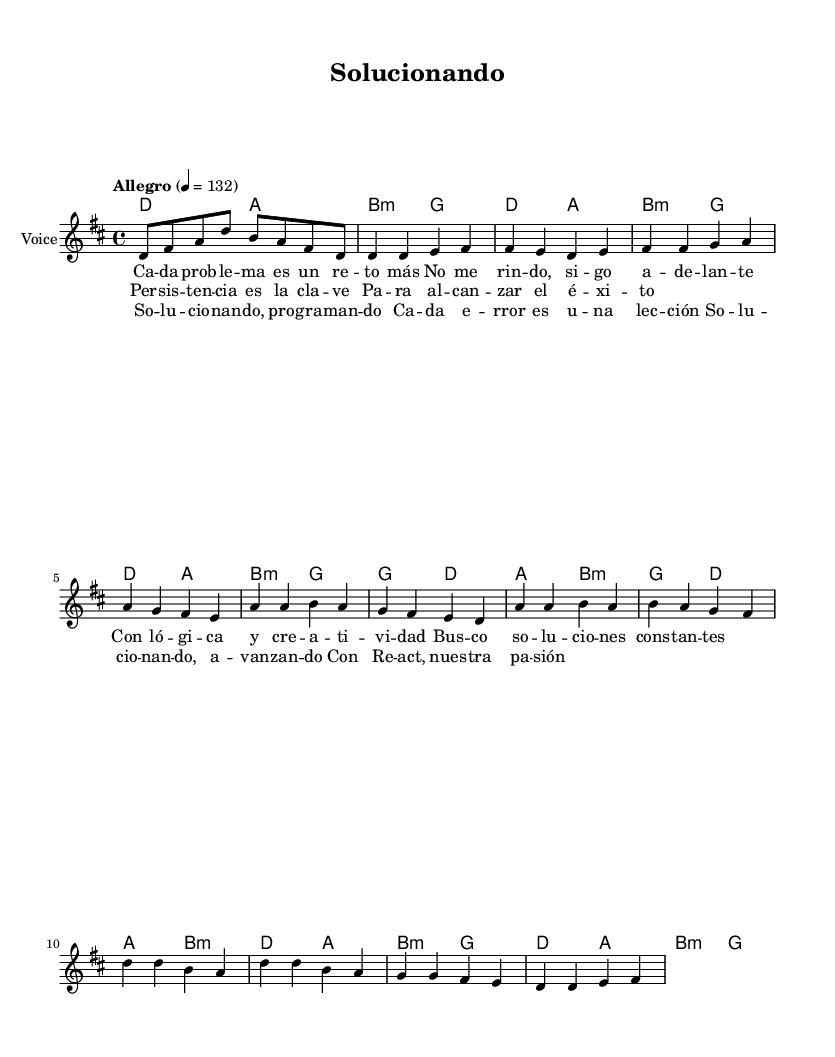What is the key signature of this music? The key signature is D major, which has F sharp and C sharp notes represented in the sheet music.
Answer: D major What is the time signature of the piece? The time signature is 4/4, indicated at the beginning of the sheet music. This means there are four beats in each measure and the quarter note gets one beat.
Answer: 4/4 What is the tempo marking for this music? The tempo marking is "Allegro" with a metronome marking of 132 beats per minute, which indicates a fast-paced tempo.
Answer: Allegro, 132 How many measures are in the chorus section? The chorus consists of four measures, as indicated by the notation within the section labeled "Chorus."
Answer: Four measures What is the main theme of the lyrics? The main theme revolves around problem-solving and persistence, discussing facing challenges and learning from mistakes as indicated in the lyrics.
Answer: Problem-solving and persistence What chord follows the A major chord in the pre-chorus? The chord that follows the A major chord in the pre-chorus is B minor, which indicates a shift in harmony within that section.
Answer: B minor What is the primary rhythmic value used in the melody? The primary rhythmic value used in the melody is the eighth note, as shown prominently in the melody line throughout the piece.
Answer: Eighth note 